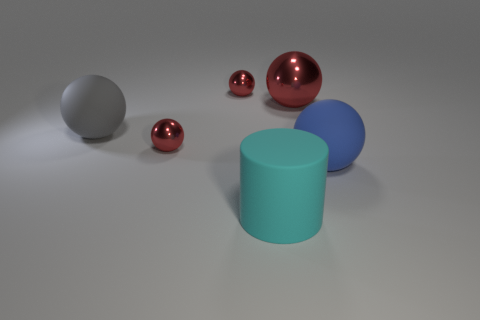Subtract all cyan cubes. How many red balls are left? 3 Subtract all blue balls. How many balls are left? 4 Subtract all gray spheres. How many spheres are left? 4 Subtract all purple spheres. Subtract all brown cylinders. How many spheres are left? 5 Add 1 tiny brown rubber objects. How many objects exist? 7 Subtract all spheres. How many objects are left? 1 Add 1 blue objects. How many blue objects exist? 2 Subtract 0 yellow blocks. How many objects are left? 6 Subtract all tiny blue cubes. Subtract all big metallic objects. How many objects are left? 5 Add 1 matte things. How many matte things are left? 4 